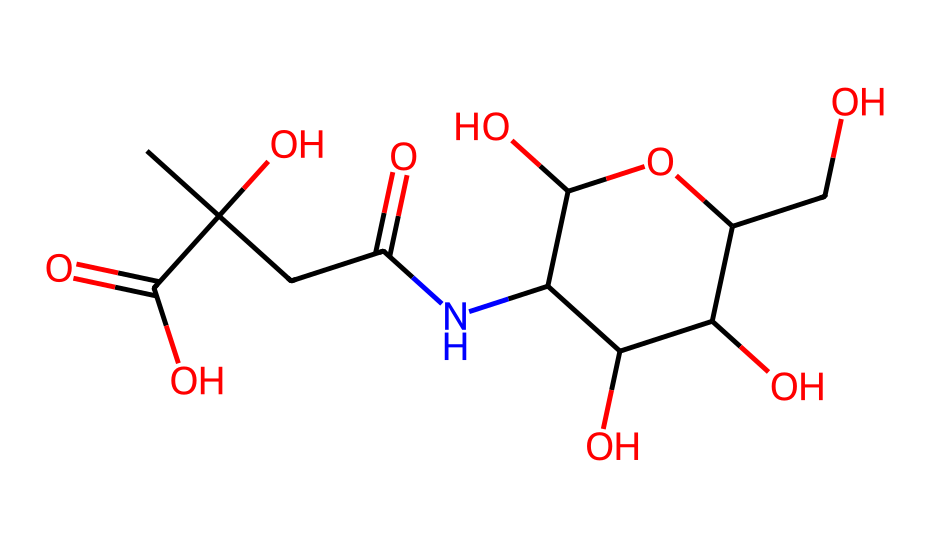What is the name of this chemical? The name given by its structure is hyaluronic acid, which is often used in skincare products for its moisturizing properties. The presence of carboxylic acid groups visible in the structure helps in identifying it as an acid, specifically hyaluronic.
Answer: hyaluronic acid How many carbon atoms are in the chemical structure? By counting the carbon atoms present in the SMILES representation, there are 11 carbon atoms that can be identified in the structure.
Answer: 11 How many functional groups are present in this chemical? The chemical contains several functional groups, primarily alcohol (hydroxyl) and carboxylic acid groups. There are a total of 4 carboxylic acid groups and multiple hydroxyls. Counting these reveals that there are multiple functional groups present, notably carboxylic and hydroxyl groups.
Answer: 6 What type of biological effect does hyaluronic acid primarily have? The primary biological effect of hyaluronic acid is moisturizing, as it has the ability to retain water and hydrate the skin. This is due to its structure, which allows it to interact with water molecules effectively.
Answer: moisturizing What is the molecular weight of hyaluronic acid? To calculate the molecular weight, one would sum the atomic weights of all atoms present in the structure: Carbon (C) contributes 12.01 g/mol, Oxygen (O) contributes 16.00 g/mol, and Nitrogen (N) adds around 14.01 g/mol. After calculating with the correct number of each atom type in the structure, the approximate molecular weight is 403. This requires detailed molecular counting and addition.
Answer: 403 